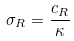<formula> <loc_0><loc_0><loc_500><loc_500>\sigma _ { R } = \frac { c _ { R } } { \kappa }</formula> 